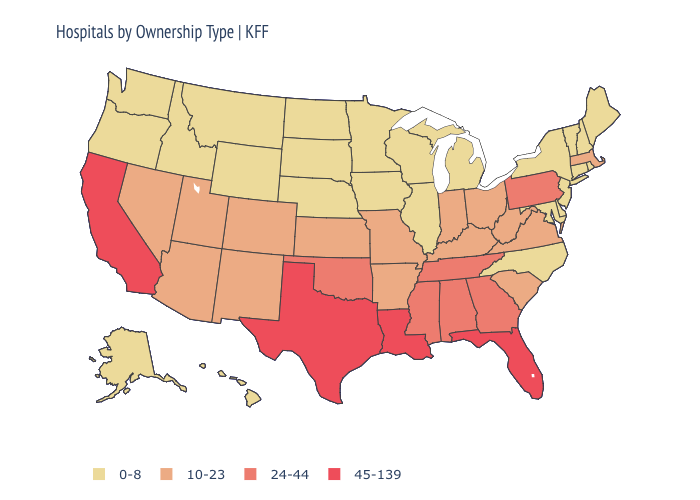Does Illinois have a lower value than Wyoming?
Give a very brief answer. No. What is the value of Wyoming?
Quick response, please. 0-8. Does Montana have the highest value in the West?
Answer briefly. No. What is the highest value in the West ?
Concise answer only. 45-139. Name the states that have a value in the range 10-23?
Short answer required. Arizona, Arkansas, Colorado, Indiana, Kansas, Kentucky, Massachusetts, Missouri, Nevada, New Mexico, Ohio, South Carolina, Utah, Virginia, West Virginia. Name the states that have a value in the range 10-23?
Quick response, please. Arizona, Arkansas, Colorado, Indiana, Kansas, Kentucky, Massachusetts, Missouri, Nevada, New Mexico, Ohio, South Carolina, Utah, Virginia, West Virginia. Among the states that border Oregon , does Idaho have the lowest value?
Answer briefly. Yes. Among the states that border Massachusetts , which have the highest value?
Short answer required. Connecticut, New Hampshire, New York, Rhode Island, Vermont. Name the states that have a value in the range 24-44?
Concise answer only. Alabama, Georgia, Mississippi, Oklahoma, Pennsylvania, Tennessee. What is the highest value in the West ?
Be succinct. 45-139. What is the value of Oklahoma?
Short answer required. 24-44. What is the highest value in states that border Texas?
Quick response, please. 45-139. What is the highest value in the USA?
Give a very brief answer. 45-139. Does the first symbol in the legend represent the smallest category?
Keep it brief. Yes. Name the states that have a value in the range 10-23?
Answer briefly. Arizona, Arkansas, Colorado, Indiana, Kansas, Kentucky, Massachusetts, Missouri, Nevada, New Mexico, Ohio, South Carolina, Utah, Virginia, West Virginia. 